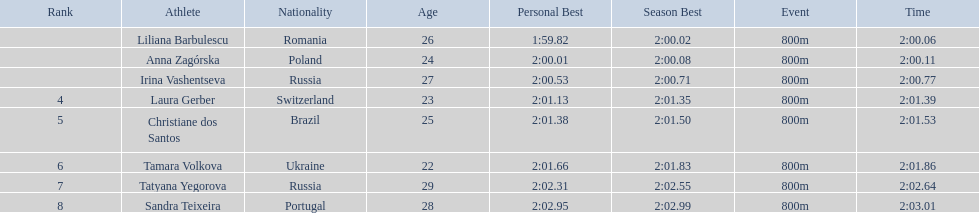What is the name of the top finalist of this semifinals heat? Liliana Barbulescu. 